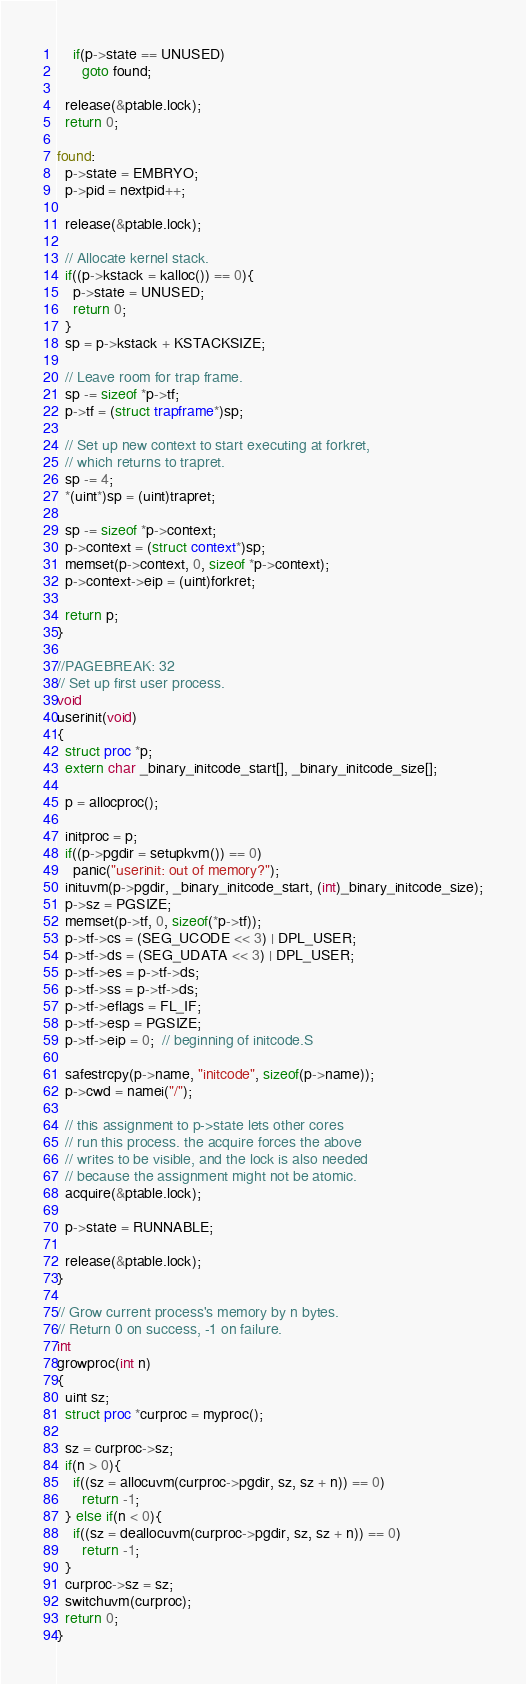Convert code to text. <code><loc_0><loc_0><loc_500><loc_500><_C_>    if(p->state == UNUSED)
      goto found;

  release(&ptable.lock);
  return 0;

found:
  p->state = EMBRYO;
  p->pid = nextpid++;

  release(&ptable.lock);

  // Allocate kernel stack.
  if((p->kstack = kalloc()) == 0){
    p->state = UNUSED;
    return 0;
  }
  sp = p->kstack + KSTACKSIZE;

  // Leave room for trap frame.
  sp -= sizeof *p->tf;
  p->tf = (struct trapframe*)sp;

  // Set up new context to start executing at forkret,
  // which returns to trapret.
  sp -= 4;
  *(uint*)sp = (uint)trapret;

  sp -= sizeof *p->context;
  p->context = (struct context*)sp;
  memset(p->context, 0, sizeof *p->context);
  p->context->eip = (uint)forkret;

  return p;
}

//PAGEBREAK: 32
// Set up first user process.
void
userinit(void)
{
  struct proc *p;
  extern char _binary_initcode_start[], _binary_initcode_size[];

  p = allocproc();
  
  initproc = p;
  if((p->pgdir = setupkvm()) == 0)
    panic("userinit: out of memory?");
  inituvm(p->pgdir, _binary_initcode_start, (int)_binary_initcode_size);
  p->sz = PGSIZE;
  memset(p->tf, 0, sizeof(*p->tf));
  p->tf->cs = (SEG_UCODE << 3) | DPL_USER;
  p->tf->ds = (SEG_UDATA << 3) | DPL_USER;
  p->tf->es = p->tf->ds;
  p->tf->ss = p->tf->ds;
  p->tf->eflags = FL_IF;
  p->tf->esp = PGSIZE;
  p->tf->eip = 0;  // beginning of initcode.S

  safestrcpy(p->name, "initcode", sizeof(p->name));
  p->cwd = namei("/");

  // this assignment to p->state lets other cores
  // run this process. the acquire forces the above
  // writes to be visible, and the lock is also needed
  // because the assignment might not be atomic.
  acquire(&ptable.lock);

  p->state = RUNNABLE;

  release(&ptable.lock);
}

// Grow current process's memory by n bytes.
// Return 0 on success, -1 on failure.
int
growproc(int n)
{
  uint sz;
  struct proc *curproc = myproc();

  sz = curproc->sz;
  if(n > 0){
    if((sz = allocuvm(curproc->pgdir, sz, sz + n)) == 0)
      return -1;
  } else if(n < 0){
    if((sz = deallocuvm(curproc->pgdir, sz, sz + n)) == 0)
      return -1;
  }
  curproc->sz = sz;
  switchuvm(curproc);
  return 0;
}
</code> 